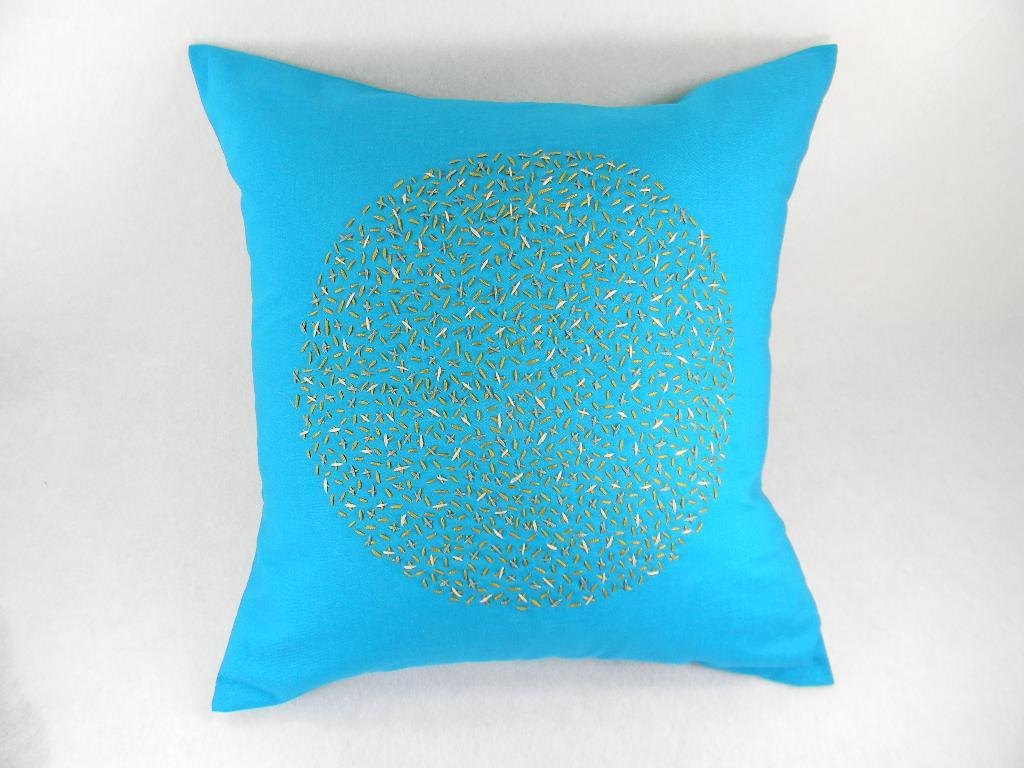What color is the pillow that is visible in the image? There is a blue color pillow in the image. What color is the background of the image? The background of the image is white in color. How many bikes are balanced on the pillow in the image? There are no bikes present in the image, and therefore no bikes are balanced on the pillow. What type of monkey can be seen sitting on the pillow in the image? There is no monkey present in the image; only the blue color pillow and white background are visible. 